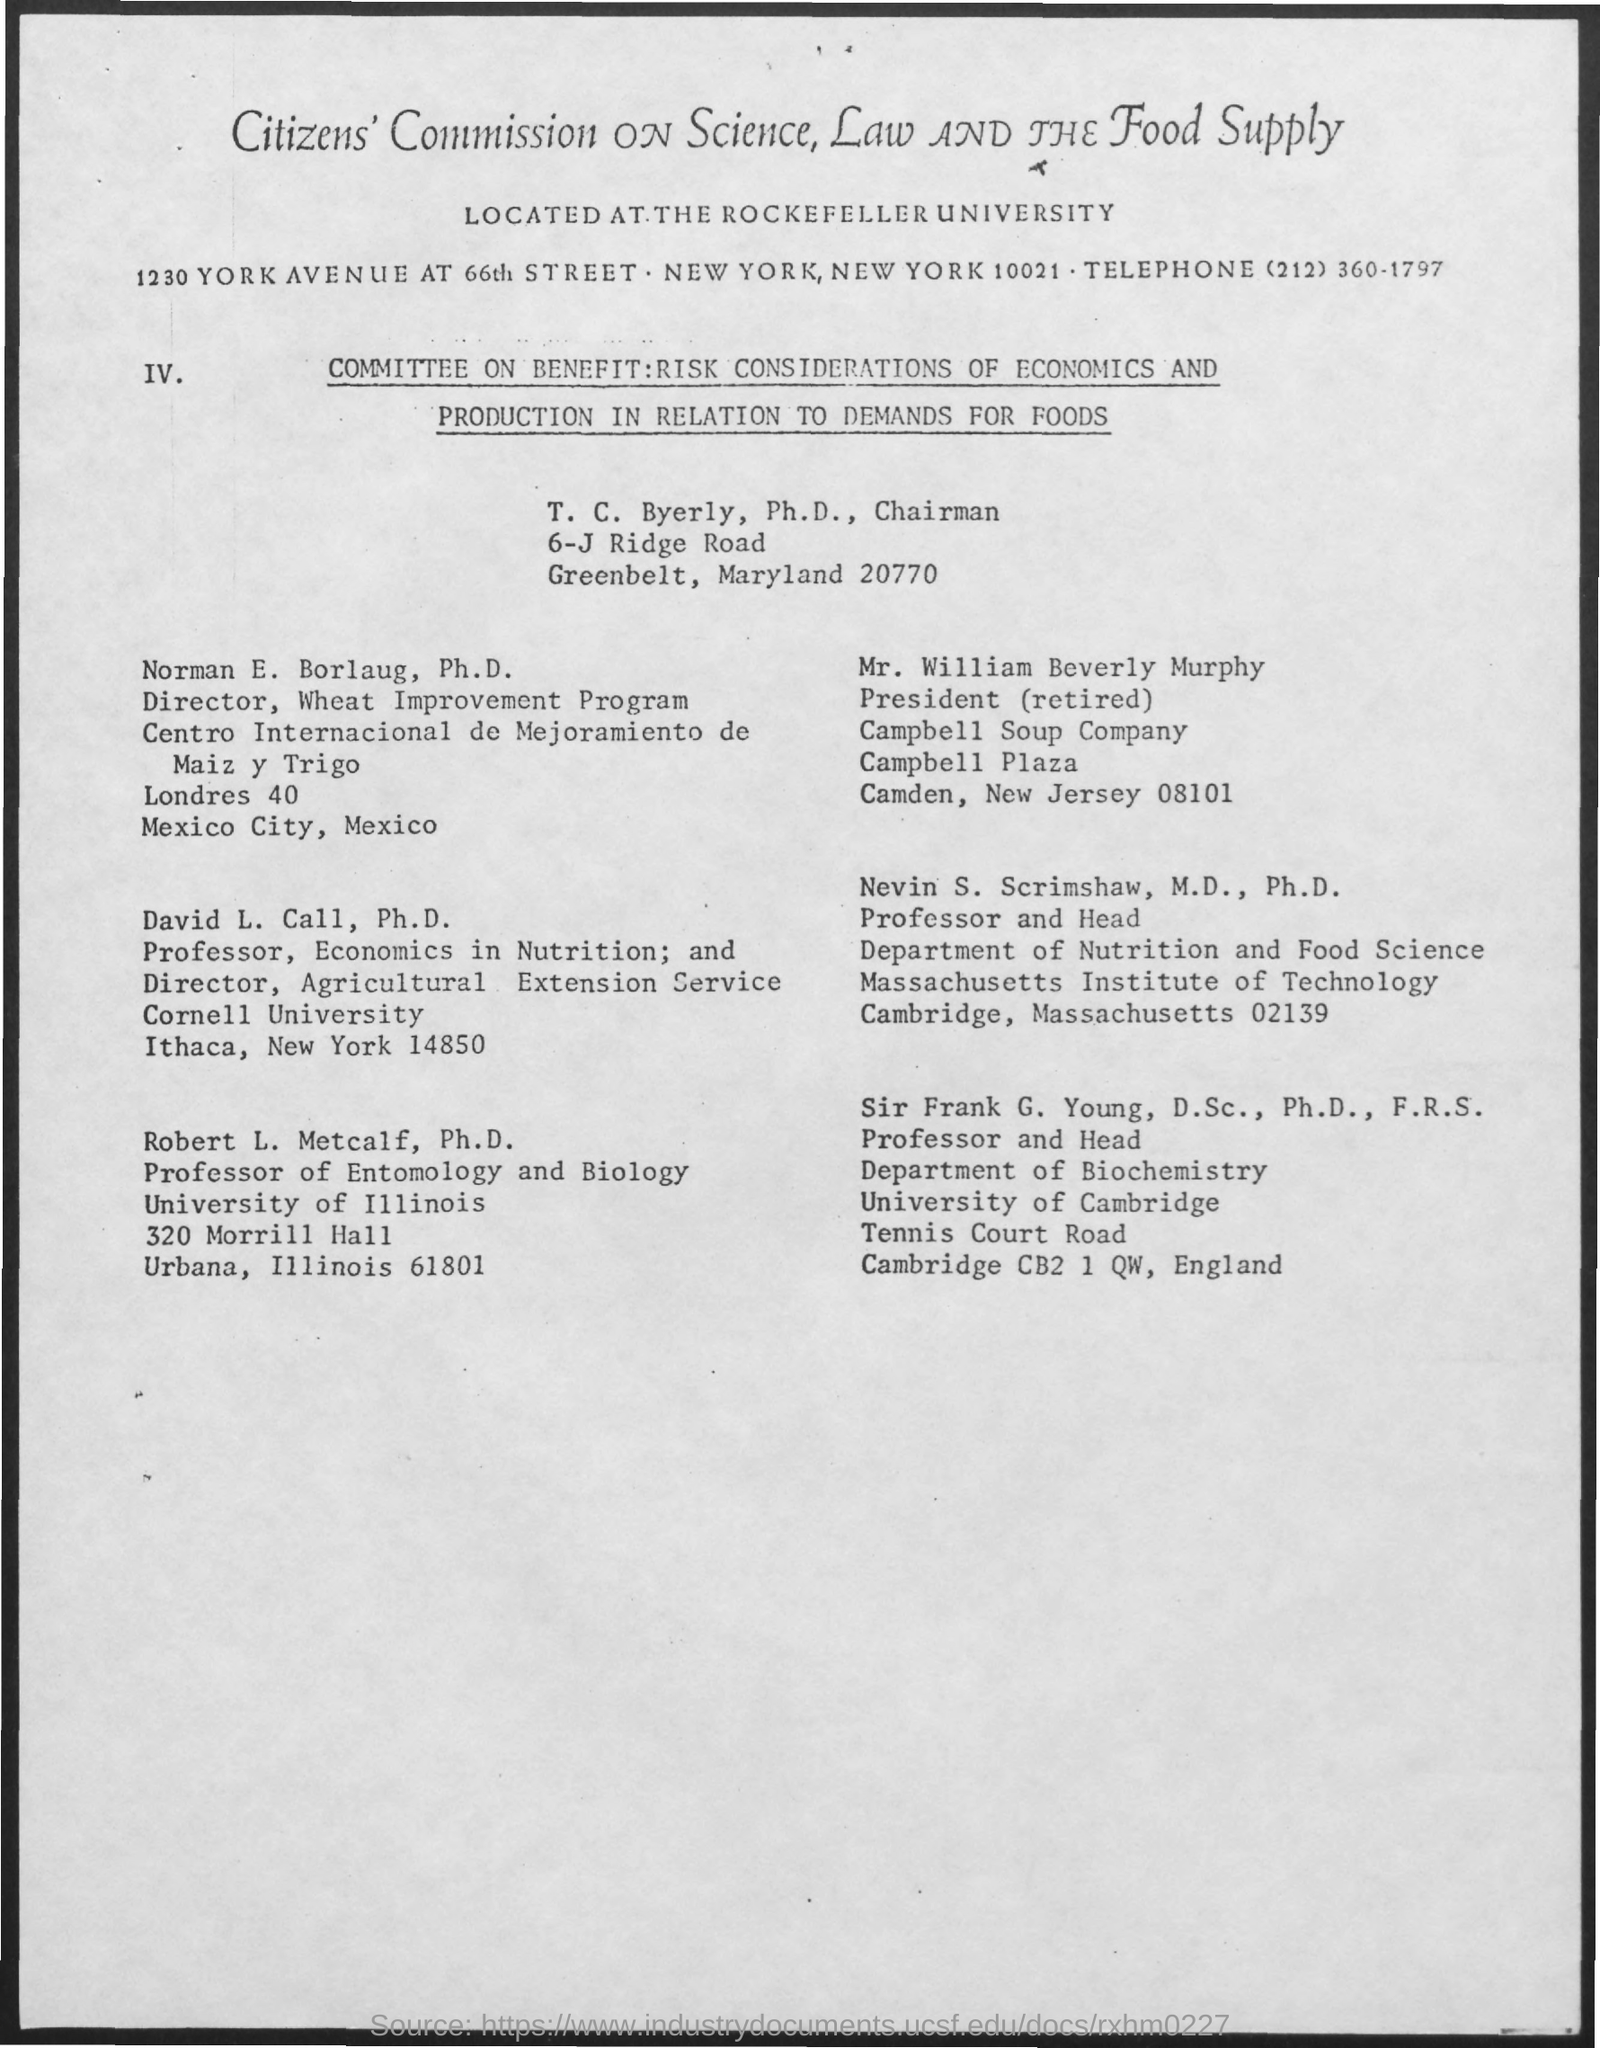Draw attention to some important aspects in this diagram. Mr. William Beverly Murphy's designation is President (Retired). The telephone number mentioned is (212) 360-1797. The name of the university mentioned in the given form is Rockefeller University. 